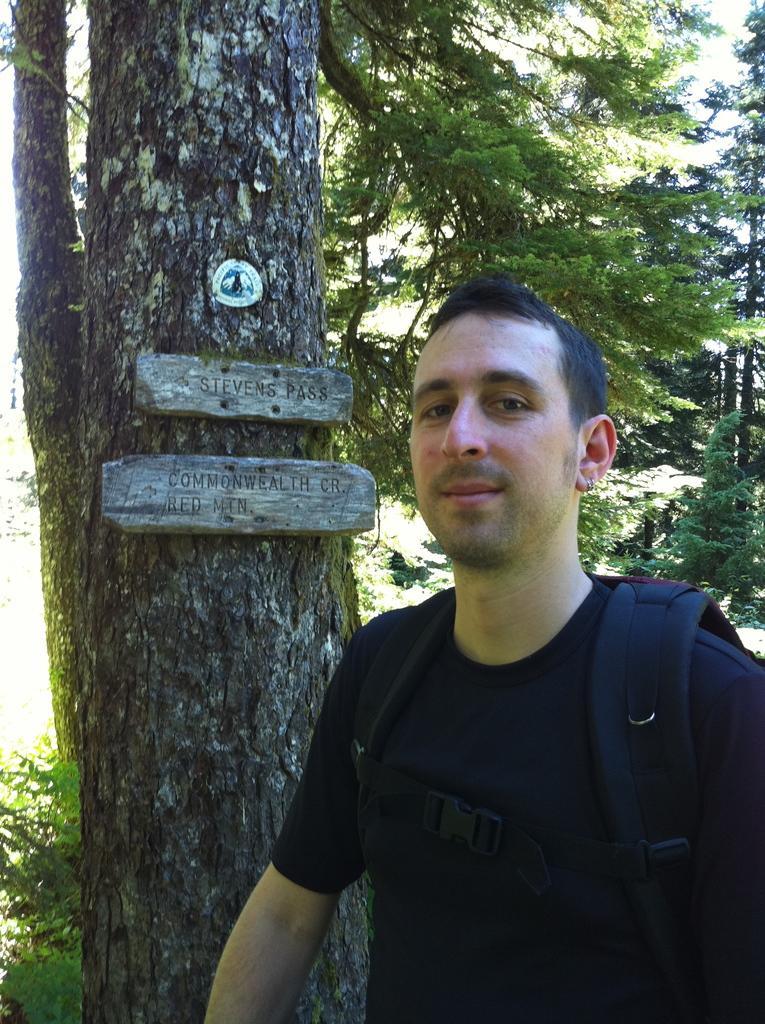How would you summarize this image in a sentence or two? In this picture we can see a man standing in front of a tree and looking at someone. 